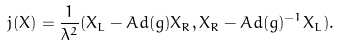<formula> <loc_0><loc_0><loc_500><loc_500>j ( X ) = \frac { 1 } { \lambda ^ { 2 } } ( X _ { L } - A d ( g ) X _ { R } , X _ { R } - A d ( g ) ^ { - 1 } X _ { L } ) .</formula> 